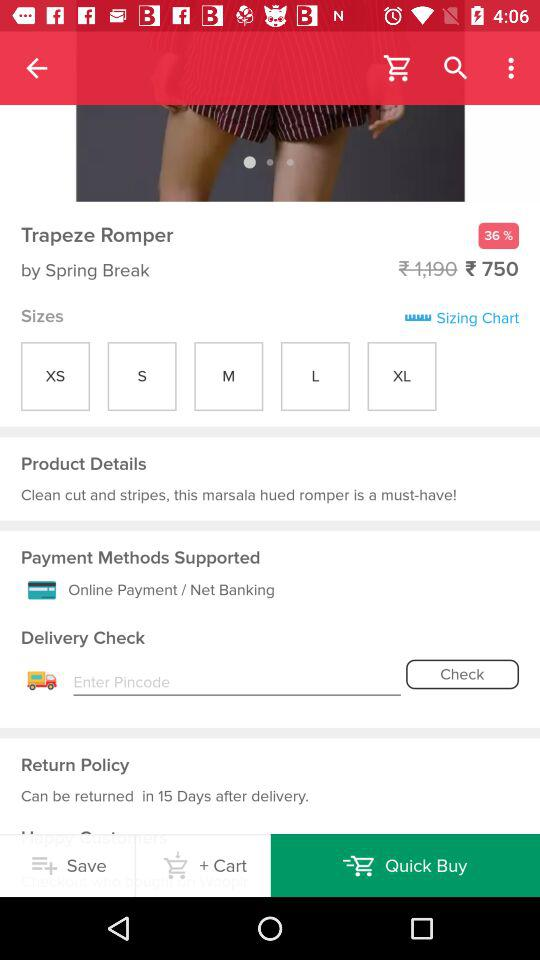How many sizes are available for this product?
Answer the question using a single word or phrase. 5 